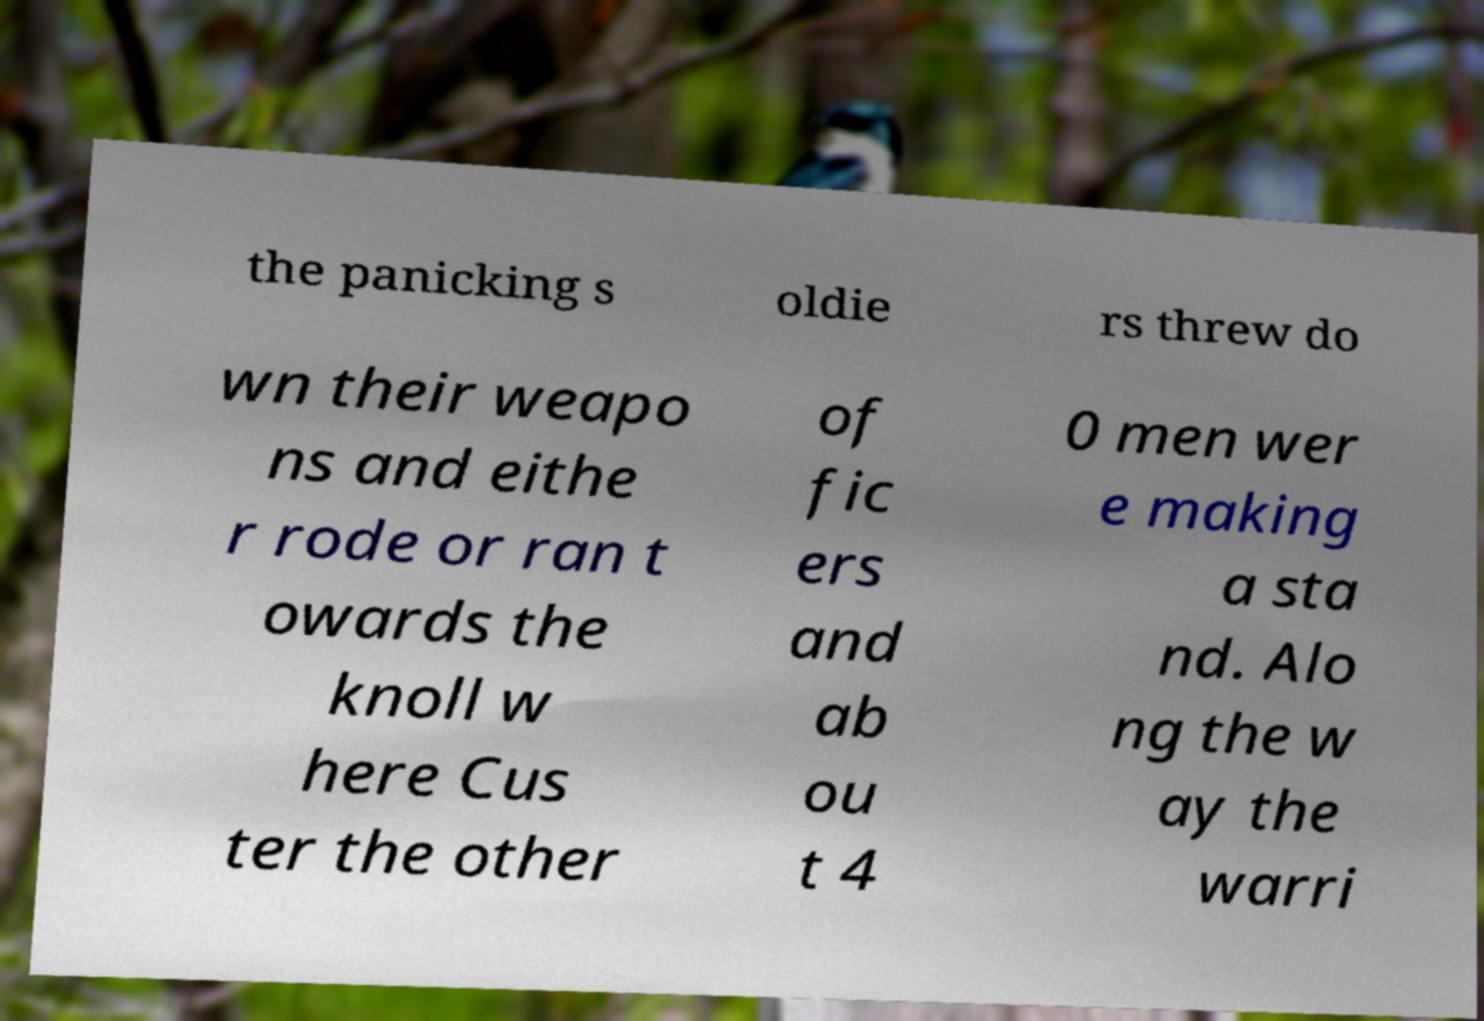I need the written content from this picture converted into text. Can you do that? the panicking s oldie rs threw do wn their weapo ns and eithe r rode or ran t owards the knoll w here Cus ter the other of fic ers and ab ou t 4 0 men wer e making a sta nd. Alo ng the w ay the warri 